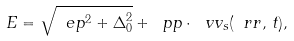Convert formula to latex. <formula><loc_0><loc_0><loc_500><loc_500>E = \sqrt { \ e p ^ { 2 } + \Delta _ { 0 } ^ { 2 } } + \ p p \cdot \ v v _ { s } ( \ r r , \, t ) ,</formula> 